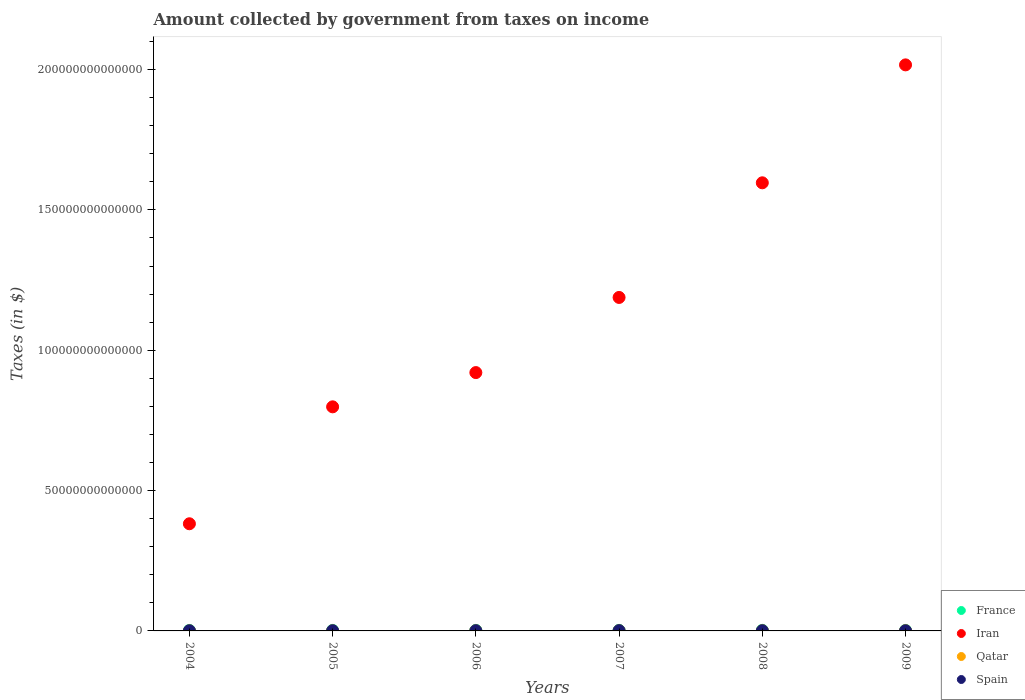How many different coloured dotlines are there?
Offer a very short reply. 4. What is the amount collected by government from taxes on income in Iran in 2007?
Your answer should be compact. 1.19e+14. Across all years, what is the maximum amount collected by government from taxes on income in France?
Make the answer very short. 2.04e+11. Across all years, what is the minimum amount collected by government from taxes on income in France?
Make the answer very short. 1.67e+11. In which year was the amount collected by government from taxes on income in Qatar minimum?
Provide a succinct answer. 2004. What is the total amount collected by government from taxes on income in Iran in the graph?
Keep it short and to the point. 6.90e+14. What is the difference between the amount collected by government from taxes on income in Iran in 2004 and that in 2007?
Provide a short and direct response. -8.06e+13. What is the difference between the amount collected by government from taxes on income in Iran in 2004 and the amount collected by government from taxes on income in Qatar in 2008?
Your answer should be compact. 3.81e+13. What is the average amount collected by government from taxes on income in Iran per year?
Keep it short and to the point. 1.15e+14. In the year 2007, what is the difference between the amount collected by government from taxes on income in Qatar and amount collected by government from taxes on income in Spain?
Ensure brevity in your answer.  -4.45e+1. In how many years, is the amount collected by government from taxes on income in Qatar greater than 60000000000000 $?
Give a very brief answer. 0. What is the ratio of the amount collected by government from taxes on income in Spain in 2007 to that in 2009?
Give a very brief answer. 1.73. Is the difference between the amount collected by government from taxes on income in Qatar in 2004 and 2007 greater than the difference between the amount collected by government from taxes on income in Spain in 2004 and 2007?
Your answer should be very brief. Yes. What is the difference between the highest and the second highest amount collected by government from taxes on income in France?
Your answer should be very brief. 6.48e+09. What is the difference between the highest and the lowest amount collected by government from taxes on income in Qatar?
Provide a short and direct response. 3.96e+1. In how many years, is the amount collected by government from taxes on income in France greater than the average amount collected by government from taxes on income in France taken over all years?
Your answer should be very brief. 3. Is the sum of the amount collected by government from taxes on income in Iran in 2006 and 2007 greater than the maximum amount collected by government from taxes on income in Qatar across all years?
Keep it short and to the point. Yes. Is it the case that in every year, the sum of the amount collected by government from taxes on income in Qatar and amount collected by government from taxes on income in France  is greater than the sum of amount collected by government from taxes on income in Spain and amount collected by government from taxes on income in Iran?
Offer a terse response. Yes. Does the amount collected by government from taxes on income in Spain monotonically increase over the years?
Your answer should be very brief. No. Is the amount collected by government from taxes on income in Iran strictly less than the amount collected by government from taxes on income in France over the years?
Give a very brief answer. No. How many dotlines are there?
Offer a very short reply. 4. What is the difference between two consecutive major ticks on the Y-axis?
Offer a very short reply. 5.00e+13. Are the values on the major ticks of Y-axis written in scientific E-notation?
Give a very brief answer. No. How are the legend labels stacked?
Offer a very short reply. Vertical. What is the title of the graph?
Give a very brief answer. Amount collected by government from taxes on income. What is the label or title of the X-axis?
Your answer should be compact. Years. What is the label or title of the Y-axis?
Ensure brevity in your answer.  Taxes (in $). What is the Taxes (in $) of France in 2004?
Make the answer very short. 1.70e+11. What is the Taxes (in $) of Iran in 2004?
Provide a succinct answer. 3.82e+13. What is the Taxes (in $) in Qatar in 2004?
Give a very brief answer. 2.83e+1. What is the Taxes (in $) in Spain in 2004?
Offer a terse response. 6.17e+1. What is the Taxes (in $) in France in 2005?
Your answer should be compact. 1.79e+11. What is the Taxes (in $) of Iran in 2005?
Your answer should be very brief. 7.98e+13. What is the Taxes (in $) of Qatar in 2005?
Make the answer very short. 3.12e+1. What is the Taxes (in $) in Spain in 2005?
Offer a terse response. 7.17e+1. What is the Taxes (in $) of France in 2006?
Offer a very short reply. 1.94e+11. What is the Taxes (in $) in Iran in 2006?
Keep it short and to the point. 9.20e+13. What is the Taxes (in $) in Qatar in 2006?
Keep it short and to the point. 4.17e+1. What is the Taxes (in $) of Spain in 2006?
Provide a short and direct response. 8.38e+1. What is the Taxes (in $) in France in 2007?
Provide a succinct answer. 1.98e+11. What is the Taxes (in $) in Iran in 2007?
Your answer should be compact. 1.19e+14. What is the Taxes (in $) in Qatar in 2007?
Give a very brief answer. 5.58e+1. What is the Taxes (in $) of Spain in 2007?
Your answer should be compact. 1.00e+11. What is the Taxes (in $) of France in 2008?
Give a very brief answer. 2.04e+11. What is the Taxes (in $) in Iran in 2008?
Offer a very short reply. 1.60e+14. What is the Taxes (in $) in Qatar in 2008?
Provide a short and direct response. 6.33e+1. What is the Taxes (in $) in Spain in 2008?
Provide a short and direct response. 7.50e+1. What is the Taxes (in $) in France in 2009?
Your answer should be compact. 1.67e+11. What is the Taxes (in $) in Iran in 2009?
Make the answer very short. 2.02e+14. What is the Taxes (in $) of Qatar in 2009?
Keep it short and to the point. 6.78e+1. What is the Taxes (in $) of Spain in 2009?
Provide a succinct answer. 5.79e+1. Across all years, what is the maximum Taxes (in $) in France?
Your response must be concise. 2.04e+11. Across all years, what is the maximum Taxes (in $) of Iran?
Provide a succinct answer. 2.02e+14. Across all years, what is the maximum Taxes (in $) in Qatar?
Ensure brevity in your answer.  6.78e+1. Across all years, what is the maximum Taxes (in $) of Spain?
Your answer should be very brief. 1.00e+11. Across all years, what is the minimum Taxes (in $) of France?
Give a very brief answer. 1.67e+11. Across all years, what is the minimum Taxes (in $) of Iran?
Your response must be concise. 3.82e+13. Across all years, what is the minimum Taxes (in $) of Qatar?
Your response must be concise. 2.83e+1. Across all years, what is the minimum Taxes (in $) in Spain?
Your answer should be very brief. 5.79e+1. What is the total Taxes (in $) of France in the graph?
Make the answer very short. 1.11e+12. What is the total Taxes (in $) of Iran in the graph?
Your response must be concise. 6.90e+14. What is the total Taxes (in $) of Qatar in the graph?
Your answer should be very brief. 2.88e+11. What is the total Taxes (in $) of Spain in the graph?
Your answer should be very brief. 4.50e+11. What is the difference between the Taxes (in $) in France in 2004 and that in 2005?
Your answer should be compact. -9.03e+09. What is the difference between the Taxes (in $) in Iran in 2004 and that in 2005?
Ensure brevity in your answer.  -4.17e+13. What is the difference between the Taxes (in $) of Qatar in 2004 and that in 2005?
Your answer should be very brief. -2.98e+09. What is the difference between the Taxes (in $) in Spain in 2004 and that in 2005?
Give a very brief answer. -1.01e+1. What is the difference between the Taxes (in $) in France in 2004 and that in 2006?
Give a very brief answer. -2.45e+1. What is the difference between the Taxes (in $) of Iran in 2004 and that in 2006?
Your answer should be compact. -5.39e+13. What is the difference between the Taxes (in $) in Qatar in 2004 and that in 2006?
Your response must be concise. -1.35e+1. What is the difference between the Taxes (in $) in Spain in 2004 and that in 2006?
Offer a terse response. -2.22e+1. What is the difference between the Taxes (in $) of France in 2004 and that in 2007?
Provide a succinct answer. -2.82e+1. What is the difference between the Taxes (in $) in Iran in 2004 and that in 2007?
Give a very brief answer. -8.06e+13. What is the difference between the Taxes (in $) in Qatar in 2004 and that in 2007?
Provide a succinct answer. -2.76e+1. What is the difference between the Taxes (in $) of Spain in 2004 and that in 2007?
Your response must be concise. -3.86e+1. What is the difference between the Taxes (in $) of France in 2004 and that in 2008?
Make the answer very short. -3.46e+1. What is the difference between the Taxes (in $) of Iran in 2004 and that in 2008?
Ensure brevity in your answer.  -1.21e+14. What is the difference between the Taxes (in $) in Qatar in 2004 and that in 2008?
Ensure brevity in your answer.  -3.50e+1. What is the difference between the Taxes (in $) of Spain in 2004 and that in 2008?
Your answer should be compact. -1.34e+1. What is the difference between the Taxes (in $) in France in 2004 and that in 2009?
Provide a short and direct response. 2.68e+09. What is the difference between the Taxes (in $) in Iran in 2004 and that in 2009?
Provide a short and direct response. -1.63e+14. What is the difference between the Taxes (in $) of Qatar in 2004 and that in 2009?
Give a very brief answer. -3.96e+1. What is the difference between the Taxes (in $) of Spain in 2004 and that in 2009?
Keep it short and to the point. 3.77e+09. What is the difference between the Taxes (in $) of France in 2005 and that in 2006?
Your response must be concise. -1.54e+1. What is the difference between the Taxes (in $) in Iran in 2005 and that in 2006?
Offer a very short reply. -1.22e+13. What is the difference between the Taxes (in $) of Qatar in 2005 and that in 2006?
Make the answer very short. -1.05e+1. What is the difference between the Taxes (in $) in Spain in 2005 and that in 2006?
Give a very brief answer. -1.21e+1. What is the difference between the Taxes (in $) of France in 2005 and that in 2007?
Give a very brief answer. -1.91e+1. What is the difference between the Taxes (in $) in Iran in 2005 and that in 2007?
Keep it short and to the point. -3.90e+13. What is the difference between the Taxes (in $) of Qatar in 2005 and that in 2007?
Provide a succinct answer. -2.46e+1. What is the difference between the Taxes (in $) in Spain in 2005 and that in 2007?
Provide a short and direct response. -2.86e+1. What is the difference between the Taxes (in $) of France in 2005 and that in 2008?
Your answer should be compact. -2.56e+1. What is the difference between the Taxes (in $) in Iran in 2005 and that in 2008?
Ensure brevity in your answer.  -7.98e+13. What is the difference between the Taxes (in $) in Qatar in 2005 and that in 2008?
Offer a very short reply. -3.20e+1. What is the difference between the Taxes (in $) of Spain in 2005 and that in 2008?
Provide a succinct answer. -3.30e+09. What is the difference between the Taxes (in $) of France in 2005 and that in 2009?
Your answer should be compact. 1.17e+1. What is the difference between the Taxes (in $) of Iran in 2005 and that in 2009?
Your answer should be compact. -1.22e+14. What is the difference between the Taxes (in $) of Qatar in 2005 and that in 2009?
Your answer should be very brief. -3.66e+1. What is the difference between the Taxes (in $) of Spain in 2005 and that in 2009?
Your answer should be very brief. 1.38e+1. What is the difference between the Taxes (in $) in France in 2006 and that in 2007?
Your response must be concise. -3.69e+09. What is the difference between the Taxes (in $) in Iran in 2006 and that in 2007?
Your answer should be compact. -2.68e+13. What is the difference between the Taxes (in $) of Qatar in 2006 and that in 2007?
Keep it short and to the point. -1.41e+1. What is the difference between the Taxes (in $) in Spain in 2006 and that in 2007?
Your answer should be very brief. -1.65e+1. What is the difference between the Taxes (in $) of France in 2006 and that in 2008?
Keep it short and to the point. -1.02e+1. What is the difference between the Taxes (in $) in Iran in 2006 and that in 2008?
Offer a terse response. -6.76e+13. What is the difference between the Taxes (in $) of Qatar in 2006 and that in 2008?
Keep it short and to the point. -2.15e+1. What is the difference between the Taxes (in $) of Spain in 2006 and that in 2008?
Your answer should be very brief. 8.80e+09. What is the difference between the Taxes (in $) of France in 2006 and that in 2009?
Your answer should be compact. 2.71e+1. What is the difference between the Taxes (in $) in Iran in 2006 and that in 2009?
Provide a short and direct response. -1.10e+14. What is the difference between the Taxes (in $) in Qatar in 2006 and that in 2009?
Your response must be concise. -2.61e+1. What is the difference between the Taxes (in $) in Spain in 2006 and that in 2009?
Give a very brief answer. 2.59e+1. What is the difference between the Taxes (in $) in France in 2007 and that in 2008?
Ensure brevity in your answer.  -6.48e+09. What is the difference between the Taxes (in $) of Iran in 2007 and that in 2008?
Provide a succinct answer. -4.08e+13. What is the difference between the Taxes (in $) in Qatar in 2007 and that in 2008?
Your response must be concise. -7.43e+09. What is the difference between the Taxes (in $) in Spain in 2007 and that in 2008?
Your answer should be very brief. 2.53e+1. What is the difference between the Taxes (in $) of France in 2007 and that in 2009?
Provide a succinct answer. 3.08e+1. What is the difference between the Taxes (in $) in Iran in 2007 and that in 2009?
Keep it short and to the point. -8.29e+13. What is the difference between the Taxes (in $) of Qatar in 2007 and that in 2009?
Give a very brief answer. -1.20e+1. What is the difference between the Taxes (in $) in Spain in 2007 and that in 2009?
Give a very brief answer. 4.24e+1. What is the difference between the Taxes (in $) in France in 2008 and that in 2009?
Keep it short and to the point. 3.73e+1. What is the difference between the Taxes (in $) of Iran in 2008 and that in 2009?
Provide a succinct answer. -4.20e+13. What is the difference between the Taxes (in $) in Qatar in 2008 and that in 2009?
Your answer should be compact. -4.54e+09. What is the difference between the Taxes (in $) of Spain in 2008 and that in 2009?
Your answer should be very brief. 1.71e+1. What is the difference between the Taxes (in $) in France in 2004 and the Taxes (in $) in Iran in 2005?
Your answer should be compact. -7.97e+13. What is the difference between the Taxes (in $) in France in 2004 and the Taxes (in $) in Qatar in 2005?
Your answer should be very brief. 1.38e+11. What is the difference between the Taxes (in $) in France in 2004 and the Taxes (in $) in Spain in 2005?
Give a very brief answer. 9.79e+1. What is the difference between the Taxes (in $) in Iran in 2004 and the Taxes (in $) in Qatar in 2005?
Provide a short and direct response. 3.81e+13. What is the difference between the Taxes (in $) in Iran in 2004 and the Taxes (in $) in Spain in 2005?
Provide a succinct answer. 3.81e+13. What is the difference between the Taxes (in $) of Qatar in 2004 and the Taxes (in $) of Spain in 2005?
Keep it short and to the point. -4.35e+1. What is the difference between the Taxes (in $) of France in 2004 and the Taxes (in $) of Iran in 2006?
Your answer should be very brief. -9.19e+13. What is the difference between the Taxes (in $) of France in 2004 and the Taxes (in $) of Qatar in 2006?
Make the answer very short. 1.28e+11. What is the difference between the Taxes (in $) of France in 2004 and the Taxes (in $) of Spain in 2006?
Keep it short and to the point. 8.58e+1. What is the difference between the Taxes (in $) in Iran in 2004 and the Taxes (in $) in Qatar in 2006?
Provide a short and direct response. 3.81e+13. What is the difference between the Taxes (in $) of Iran in 2004 and the Taxes (in $) of Spain in 2006?
Ensure brevity in your answer.  3.81e+13. What is the difference between the Taxes (in $) of Qatar in 2004 and the Taxes (in $) of Spain in 2006?
Your answer should be very brief. -5.56e+1. What is the difference between the Taxes (in $) of France in 2004 and the Taxes (in $) of Iran in 2007?
Your answer should be compact. -1.19e+14. What is the difference between the Taxes (in $) of France in 2004 and the Taxes (in $) of Qatar in 2007?
Ensure brevity in your answer.  1.14e+11. What is the difference between the Taxes (in $) in France in 2004 and the Taxes (in $) in Spain in 2007?
Keep it short and to the point. 6.94e+1. What is the difference between the Taxes (in $) of Iran in 2004 and the Taxes (in $) of Qatar in 2007?
Offer a very short reply. 3.81e+13. What is the difference between the Taxes (in $) in Iran in 2004 and the Taxes (in $) in Spain in 2007?
Offer a terse response. 3.81e+13. What is the difference between the Taxes (in $) in Qatar in 2004 and the Taxes (in $) in Spain in 2007?
Make the answer very short. -7.20e+1. What is the difference between the Taxes (in $) in France in 2004 and the Taxes (in $) in Iran in 2008?
Your response must be concise. -1.59e+14. What is the difference between the Taxes (in $) of France in 2004 and the Taxes (in $) of Qatar in 2008?
Your answer should be compact. 1.06e+11. What is the difference between the Taxes (in $) in France in 2004 and the Taxes (in $) in Spain in 2008?
Your response must be concise. 9.46e+1. What is the difference between the Taxes (in $) of Iran in 2004 and the Taxes (in $) of Qatar in 2008?
Give a very brief answer. 3.81e+13. What is the difference between the Taxes (in $) in Iran in 2004 and the Taxes (in $) in Spain in 2008?
Provide a short and direct response. 3.81e+13. What is the difference between the Taxes (in $) in Qatar in 2004 and the Taxes (in $) in Spain in 2008?
Offer a very short reply. -4.68e+1. What is the difference between the Taxes (in $) of France in 2004 and the Taxes (in $) of Iran in 2009?
Provide a short and direct response. -2.01e+14. What is the difference between the Taxes (in $) of France in 2004 and the Taxes (in $) of Qatar in 2009?
Provide a short and direct response. 1.02e+11. What is the difference between the Taxes (in $) in France in 2004 and the Taxes (in $) in Spain in 2009?
Your response must be concise. 1.12e+11. What is the difference between the Taxes (in $) in Iran in 2004 and the Taxes (in $) in Qatar in 2009?
Your answer should be compact. 3.81e+13. What is the difference between the Taxes (in $) of Iran in 2004 and the Taxes (in $) of Spain in 2009?
Make the answer very short. 3.81e+13. What is the difference between the Taxes (in $) of Qatar in 2004 and the Taxes (in $) of Spain in 2009?
Ensure brevity in your answer.  -2.97e+1. What is the difference between the Taxes (in $) of France in 2005 and the Taxes (in $) of Iran in 2006?
Ensure brevity in your answer.  -9.19e+13. What is the difference between the Taxes (in $) in France in 2005 and the Taxes (in $) in Qatar in 2006?
Make the answer very short. 1.37e+11. What is the difference between the Taxes (in $) of France in 2005 and the Taxes (in $) of Spain in 2006?
Make the answer very short. 9.49e+1. What is the difference between the Taxes (in $) in Iran in 2005 and the Taxes (in $) in Qatar in 2006?
Offer a very short reply. 7.98e+13. What is the difference between the Taxes (in $) in Iran in 2005 and the Taxes (in $) in Spain in 2006?
Ensure brevity in your answer.  7.98e+13. What is the difference between the Taxes (in $) of Qatar in 2005 and the Taxes (in $) of Spain in 2006?
Make the answer very short. -5.26e+1. What is the difference between the Taxes (in $) in France in 2005 and the Taxes (in $) in Iran in 2007?
Offer a terse response. -1.19e+14. What is the difference between the Taxes (in $) of France in 2005 and the Taxes (in $) of Qatar in 2007?
Your answer should be very brief. 1.23e+11. What is the difference between the Taxes (in $) of France in 2005 and the Taxes (in $) of Spain in 2007?
Provide a succinct answer. 7.84e+1. What is the difference between the Taxes (in $) of Iran in 2005 and the Taxes (in $) of Qatar in 2007?
Your answer should be very brief. 7.98e+13. What is the difference between the Taxes (in $) of Iran in 2005 and the Taxes (in $) of Spain in 2007?
Your answer should be very brief. 7.97e+13. What is the difference between the Taxes (in $) in Qatar in 2005 and the Taxes (in $) in Spain in 2007?
Ensure brevity in your answer.  -6.91e+1. What is the difference between the Taxes (in $) in France in 2005 and the Taxes (in $) in Iran in 2008?
Give a very brief answer. -1.59e+14. What is the difference between the Taxes (in $) in France in 2005 and the Taxes (in $) in Qatar in 2008?
Your answer should be compact. 1.15e+11. What is the difference between the Taxes (in $) in France in 2005 and the Taxes (in $) in Spain in 2008?
Your answer should be compact. 1.04e+11. What is the difference between the Taxes (in $) in Iran in 2005 and the Taxes (in $) in Qatar in 2008?
Offer a very short reply. 7.98e+13. What is the difference between the Taxes (in $) in Iran in 2005 and the Taxes (in $) in Spain in 2008?
Offer a very short reply. 7.98e+13. What is the difference between the Taxes (in $) in Qatar in 2005 and the Taxes (in $) in Spain in 2008?
Your response must be concise. -4.38e+1. What is the difference between the Taxes (in $) of France in 2005 and the Taxes (in $) of Iran in 2009?
Make the answer very short. -2.01e+14. What is the difference between the Taxes (in $) of France in 2005 and the Taxes (in $) of Qatar in 2009?
Offer a very short reply. 1.11e+11. What is the difference between the Taxes (in $) of France in 2005 and the Taxes (in $) of Spain in 2009?
Provide a succinct answer. 1.21e+11. What is the difference between the Taxes (in $) in Iran in 2005 and the Taxes (in $) in Qatar in 2009?
Ensure brevity in your answer.  7.98e+13. What is the difference between the Taxes (in $) of Iran in 2005 and the Taxes (in $) of Spain in 2009?
Make the answer very short. 7.98e+13. What is the difference between the Taxes (in $) in Qatar in 2005 and the Taxes (in $) in Spain in 2009?
Your answer should be compact. -2.67e+1. What is the difference between the Taxes (in $) of France in 2006 and the Taxes (in $) of Iran in 2007?
Provide a succinct answer. -1.19e+14. What is the difference between the Taxes (in $) in France in 2006 and the Taxes (in $) in Qatar in 2007?
Your answer should be compact. 1.38e+11. What is the difference between the Taxes (in $) in France in 2006 and the Taxes (in $) in Spain in 2007?
Ensure brevity in your answer.  9.38e+1. What is the difference between the Taxes (in $) of Iran in 2006 and the Taxes (in $) of Qatar in 2007?
Make the answer very short. 9.20e+13. What is the difference between the Taxes (in $) in Iran in 2006 and the Taxes (in $) in Spain in 2007?
Ensure brevity in your answer.  9.19e+13. What is the difference between the Taxes (in $) in Qatar in 2006 and the Taxes (in $) in Spain in 2007?
Your response must be concise. -5.86e+1. What is the difference between the Taxes (in $) in France in 2006 and the Taxes (in $) in Iran in 2008?
Your answer should be very brief. -1.59e+14. What is the difference between the Taxes (in $) in France in 2006 and the Taxes (in $) in Qatar in 2008?
Keep it short and to the point. 1.31e+11. What is the difference between the Taxes (in $) of France in 2006 and the Taxes (in $) of Spain in 2008?
Your answer should be very brief. 1.19e+11. What is the difference between the Taxes (in $) of Iran in 2006 and the Taxes (in $) of Qatar in 2008?
Keep it short and to the point. 9.20e+13. What is the difference between the Taxes (in $) in Iran in 2006 and the Taxes (in $) in Spain in 2008?
Offer a terse response. 9.20e+13. What is the difference between the Taxes (in $) in Qatar in 2006 and the Taxes (in $) in Spain in 2008?
Make the answer very short. -3.33e+1. What is the difference between the Taxes (in $) of France in 2006 and the Taxes (in $) of Iran in 2009?
Keep it short and to the point. -2.01e+14. What is the difference between the Taxes (in $) of France in 2006 and the Taxes (in $) of Qatar in 2009?
Your response must be concise. 1.26e+11. What is the difference between the Taxes (in $) of France in 2006 and the Taxes (in $) of Spain in 2009?
Your answer should be very brief. 1.36e+11. What is the difference between the Taxes (in $) in Iran in 2006 and the Taxes (in $) in Qatar in 2009?
Keep it short and to the point. 9.20e+13. What is the difference between the Taxes (in $) of Iran in 2006 and the Taxes (in $) of Spain in 2009?
Keep it short and to the point. 9.20e+13. What is the difference between the Taxes (in $) in Qatar in 2006 and the Taxes (in $) in Spain in 2009?
Ensure brevity in your answer.  -1.62e+1. What is the difference between the Taxes (in $) in France in 2007 and the Taxes (in $) in Iran in 2008?
Give a very brief answer. -1.59e+14. What is the difference between the Taxes (in $) of France in 2007 and the Taxes (in $) of Qatar in 2008?
Offer a very short reply. 1.35e+11. What is the difference between the Taxes (in $) in France in 2007 and the Taxes (in $) in Spain in 2008?
Ensure brevity in your answer.  1.23e+11. What is the difference between the Taxes (in $) in Iran in 2007 and the Taxes (in $) in Qatar in 2008?
Your response must be concise. 1.19e+14. What is the difference between the Taxes (in $) of Iran in 2007 and the Taxes (in $) of Spain in 2008?
Your answer should be compact. 1.19e+14. What is the difference between the Taxes (in $) in Qatar in 2007 and the Taxes (in $) in Spain in 2008?
Offer a terse response. -1.92e+1. What is the difference between the Taxes (in $) of France in 2007 and the Taxes (in $) of Iran in 2009?
Keep it short and to the point. -2.01e+14. What is the difference between the Taxes (in $) of France in 2007 and the Taxes (in $) of Qatar in 2009?
Your answer should be compact. 1.30e+11. What is the difference between the Taxes (in $) in France in 2007 and the Taxes (in $) in Spain in 2009?
Give a very brief answer. 1.40e+11. What is the difference between the Taxes (in $) of Iran in 2007 and the Taxes (in $) of Qatar in 2009?
Keep it short and to the point. 1.19e+14. What is the difference between the Taxes (in $) in Iran in 2007 and the Taxes (in $) in Spain in 2009?
Your response must be concise. 1.19e+14. What is the difference between the Taxes (in $) of Qatar in 2007 and the Taxes (in $) of Spain in 2009?
Offer a very short reply. -2.07e+09. What is the difference between the Taxes (in $) of France in 2008 and the Taxes (in $) of Iran in 2009?
Your answer should be very brief. -2.01e+14. What is the difference between the Taxes (in $) in France in 2008 and the Taxes (in $) in Qatar in 2009?
Give a very brief answer. 1.36e+11. What is the difference between the Taxes (in $) in France in 2008 and the Taxes (in $) in Spain in 2009?
Your answer should be very brief. 1.46e+11. What is the difference between the Taxes (in $) of Iran in 2008 and the Taxes (in $) of Qatar in 2009?
Your answer should be compact. 1.60e+14. What is the difference between the Taxes (in $) in Iran in 2008 and the Taxes (in $) in Spain in 2009?
Your answer should be compact. 1.60e+14. What is the difference between the Taxes (in $) in Qatar in 2008 and the Taxes (in $) in Spain in 2009?
Provide a short and direct response. 5.36e+09. What is the average Taxes (in $) in France per year?
Provide a short and direct response. 1.85e+11. What is the average Taxes (in $) of Iran per year?
Ensure brevity in your answer.  1.15e+14. What is the average Taxes (in $) in Qatar per year?
Your response must be concise. 4.80e+1. What is the average Taxes (in $) in Spain per year?
Your answer should be compact. 7.51e+1. In the year 2004, what is the difference between the Taxes (in $) in France and Taxes (in $) in Iran?
Provide a short and direct response. -3.80e+13. In the year 2004, what is the difference between the Taxes (in $) of France and Taxes (in $) of Qatar?
Provide a short and direct response. 1.41e+11. In the year 2004, what is the difference between the Taxes (in $) in France and Taxes (in $) in Spain?
Give a very brief answer. 1.08e+11. In the year 2004, what is the difference between the Taxes (in $) in Iran and Taxes (in $) in Qatar?
Keep it short and to the point. 3.81e+13. In the year 2004, what is the difference between the Taxes (in $) of Iran and Taxes (in $) of Spain?
Offer a terse response. 3.81e+13. In the year 2004, what is the difference between the Taxes (in $) of Qatar and Taxes (in $) of Spain?
Give a very brief answer. -3.34e+1. In the year 2005, what is the difference between the Taxes (in $) in France and Taxes (in $) in Iran?
Your response must be concise. -7.97e+13. In the year 2005, what is the difference between the Taxes (in $) of France and Taxes (in $) of Qatar?
Ensure brevity in your answer.  1.47e+11. In the year 2005, what is the difference between the Taxes (in $) of France and Taxes (in $) of Spain?
Offer a terse response. 1.07e+11. In the year 2005, what is the difference between the Taxes (in $) in Iran and Taxes (in $) in Qatar?
Your response must be concise. 7.98e+13. In the year 2005, what is the difference between the Taxes (in $) of Iran and Taxes (in $) of Spain?
Offer a terse response. 7.98e+13. In the year 2005, what is the difference between the Taxes (in $) in Qatar and Taxes (in $) in Spain?
Make the answer very short. -4.05e+1. In the year 2006, what is the difference between the Taxes (in $) in France and Taxes (in $) in Iran?
Your answer should be compact. -9.18e+13. In the year 2006, what is the difference between the Taxes (in $) of France and Taxes (in $) of Qatar?
Keep it short and to the point. 1.52e+11. In the year 2006, what is the difference between the Taxes (in $) in France and Taxes (in $) in Spain?
Offer a terse response. 1.10e+11. In the year 2006, what is the difference between the Taxes (in $) of Iran and Taxes (in $) of Qatar?
Provide a short and direct response. 9.20e+13. In the year 2006, what is the difference between the Taxes (in $) in Iran and Taxes (in $) in Spain?
Ensure brevity in your answer.  9.20e+13. In the year 2006, what is the difference between the Taxes (in $) of Qatar and Taxes (in $) of Spain?
Your answer should be very brief. -4.21e+1. In the year 2007, what is the difference between the Taxes (in $) in France and Taxes (in $) in Iran?
Ensure brevity in your answer.  -1.19e+14. In the year 2007, what is the difference between the Taxes (in $) of France and Taxes (in $) of Qatar?
Offer a terse response. 1.42e+11. In the year 2007, what is the difference between the Taxes (in $) of France and Taxes (in $) of Spain?
Make the answer very short. 9.75e+1. In the year 2007, what is the difference between the Taxes (in $) in Iran and Taxes (in $) in Qatar?
Offer a very short reply. 1.19e+14. In the year 2007, what is the difference between the Taxes (in $) of Iran and Taxes (in $) of Spain?
Your response must be concise. 1.19e+14. In the year 2007, what is the difference between the Taxes (in $) of Qatar and Taxes (in $) of Spain?
Provide a succinct answer. -4.45e+1. In the year 2008, what is the difference between the Taxes (in $) of France and Taxes (in $) of Iran?
Give a very brief answer. -1.59e+14. In the year 2008, what is the difference between the Taxes (in $) in France and Taxes (in $) in Qatar?
Offer a very short reply. 1.41e+11. In the year 2008, what is the difference between the Taxes (in $) in France and Taxes (in $) in Spain?
Provide a short and direct response. 1.29e+11. In the year 2008, what is the difference between the Taxes (in $) in Iran and Taxes (in $) in Qatar?
Provide a short and direct response. 1.60e+14. In the year 2008, what is the difference between the Taxes (in $) in Iran and Taxes (in $) in Spain?
Offer a terse response. 1.60e+14. In the year 2008, what is the difference between the Taxes (in $) of Qatar and Taxes (in $) of Spain?
Keep it short and to the point. -1.18e+1. In the year 2009, what is the difference between the Taxes (in $) in France and Taxes (in $) in Iran?
Offer a terse response. -2.01e+14. In the year 2009, what is the difference between the Taxes (in $) in France and Taxes (in $) in Qatar?
Your answer should be very brief. 9.92e+1. In the year 2009, what is the difference between the Taxes (in $) in France and Taxes (in $) in Spain?
Ensure brevity in your answer.  1.09e+11. In the year 2009, what is the difference between the Taxes (in $) of Iran and Taxes (in $) of Qatar?
Your answer should be compact. 2.02e+14. In the year 2009, what is the difference between the Taxes (in $) of Iran and Taxes (in $) of Spain?
Offer a terse response. 2.02e+14. In the year 2009, what is the difference between the Taxes (in $) of Qatar and Taxes (in $) of Spain?
Your answer should be very brief. 9.90e+09. What is the ratio of the Taxes (in $) of France in 2004 to that in 2005?
Your answer should be compact. 0.95. What is the ratio of the Taxes (in $) of Iran in 2004 to that in 2005?
Offer a very short reply. 0.48. What is the ratio of the Taxes (in $) of Qatar in 2004 to that in 2005?
Ensure brevity in your answer.  0.9. What is the ratio of the Taxes (in $) of Spain in 2004 to that in 2005?
Make the answer very short. 0.86. What is the ratio of the Taxes (in $) of France in 2004 to that in 2006?
Offer a terse response. 0.87. What is the ratio of the Taxes (in $) of Iran in 2004 to that in 2006?
Your answer should be compact. 0.41. What is the ratio of the Taxes (in $) in Qatar in 2004 to that in 2006?
Offer a very short reply. 0.68. What is the ratio of the Taxes (in $) in Spain in 2004 to that in 2006?
Your answer should be very brief. 0.74. What is the ratio of the Taxes (in $) in France in 2004 to that in 2007?
Offer a very short reply. 0.86. What is the ratio of the Taxes (in $) in Iran in 2004 to that in 2007?
Your response must be concise. 0.32. What is the ratio of the Taxes (in $) in Qatar in 2004 to that in 2007?
Provide a short and direct response. 0.51. What is the ratio of the Taxes (in $) of Spain in 2004 to that in 2007?
Give a very brief answer. 0.61. What is the ratio of the Taxes (in $) of France in 2004 to that in 2008?
Give a very brief answer. 0.83. What is the ratio of the Taxes (in $) in Iran in 2004 to that in 2008?
Give a very brief answer. 0.24. What is the ratio of the Taxes (in $) of Qatar in 2004 to that in 2008?
Provide a short and direct response. 0.45. What is the ratio of the Taxes (in $) in Spain in 2004 to that in 2008?
Your answer should be compact. 0.82. What is the ratio of the Taxes (in $) of France in 2004 to that in 2009?
Make the answer very short. 1.02. What is the ratio of the Taxes (in $) in Iran in 2004 to that in 2009?
Ensure brevity in your answer.  0.19. What is the ratio of the Taxes (in $) of Qatar in 2004 to that in 2009?
Offer a very short reply. 0.42. What is the ratio of the Taxes (in $) of Spain in 2004 to that in 2009?
Give a very brief answer. 1.06. What is the ratio of the Taxes (in $) in France in 2005 to that in 2006?
Offer a very short reply. 0.92. What is the ratio of the Taxes (in $) of Iran in 2005 to that in 2006?
Offer a terse response. 0.87. What is the ratio of the Taxes (in $) in Qatar in 2005 to that in 2006?
Offer a terse response. 0.75. What is the ratio of the Taxes (in $) of Spain in 2005 to that in 2006?
Your answer should be very brief. 0.86. What is the ratio of the Taxes (in $) of France in 2005 to that in 2007?
Your response must be concise. 0.9. What is the ratio of the Taxes (in $) of Iran in 2005 to that in 2007?
Provide a short and direct response. 0.67. What is the ratio of the Taxes (in $) of Qatar in 2005 to that in 2007?
Give a very brief answer. 0.56. What is the ratio of the Taxes (in $) of Spain in 2005 to that in 2007?
Give a very brief answer. 0.72. What is the ratio of the Taxes (in $) of France in 2005 to that in 2008?
Your response must be concise. 0.87. What is the ratio of the Taxes (in $) of Iran in 2005 to that in 2008?
Your answer should be compact. 0.5. What is the ratio of the Taxes (in $) in Qatar in 2005 to that in 2008?
Provide a succinct answer. 0.49. What is the ratio of the Taxes (in $) in Spain in 2005 to that in 2008?
Your response must be concise. 0.96. What is the ratio of the Taxes (in $) in France in 2005 to that in 2009?
Your response must be concise. 1.07. What is the ratio of the Taxes (in $) in Iran in 2005 to that in 2009?
Your answer should be very brief. 0.4. What is the ratio of the Taxes (in $) in Qatar in 2005 to that in 2009?
Make the answer very short. 0.46. What is the ratio of the Taxes (in $) in Spain in 2005 to that in 2009?
Provide a short and direct response. 1.24. What is the ratio of the Taxes (in $) in France in 2006 to that in 2007?
Provide a short and direct response. 0.98. What is the ratio of the Taxes (in $) of Iran in 2006 to that in 2007?
Offer a very short reply. 0.77. What is the ratio of the Taxes (in $) of Qatar in 2006 to that in 2007?
Ensure brevity in your answer.  0.75. What is the ratio of the Taxes (in $) of Spain in 2006 to that in 2007?
Provide a succinct answer. 0.84. What is the ratio of the Taxes (in $) of France in 2006 to that in 2008?
Provide a succinct answer. 0.95. What is the ratio of the Taxes (in $) in Iran in 2006 to that in 2008?
Provide a short and direct response. 0.58. What is the ratio of the Taxes (in $) of Qatar in 2006 to that in 2008?
Offer a terse response. 0.66. What is the ratio of the Taxes (in $) of Spain in 2006 to that in 2008?
Your answer should be very brief. 1.12. What is the ratio of the Taxes (in $) in France in 2006 to that in 2009?
Offer a terse response. 1.16. What is the ratio of the Taxes (in $) in Iran in 2006 to that in 2009?
Provide a short and direct response. 0.46. What is the ratio of the Taxes (in $) in Qatar in 2006 to that in 2009?
Make the answer very short. 0.62. What is the ratio of the Taxes (in $) of Spain in 2006 to that in 2009?
Your answer should be compact. 1.45. What is the ratio of the Taxes (in $) of France in 2007 to that in 2008?
Your answer should be compact. 0.97. What is the ratio of the Taxes (in $) of Iran in 2007 to that in 2008?
Offer a terse response. 0.74. What is the ratio of the Taxes (in $) of Qatar in 2007 to that in 2008?
Provide a succinct answer. 0.88. What is the ratio of the Taxes (in $) in Spain in 2007 to that in 2008?
Provide a short and direct response. 1.34. What is the ratio of the Taxes (in $) of France in 2007 to that in 2009?
Provide a short and direct response. 1.18. What is the ratio of the Taxes (in $) of Iran in 2007 to that in 2009?
Your response must be concise. 0.59. What is the ratio of the Taxes (in $) of Qatar in 2007 to that in 2009?
Provide a succinct answer. 0.82. What is the ratio of the Taxes (in $) in Spain in 2007 to that in 2009?
Provide a short and direct response. 1.73. What is the ratio of the Taxes (in $) in France in 2008 to that in 2009?
Provide a succinct answer. 1.22. What is the ratio of the Taxes (in $) of Iran in 2008 to that in 2009?
Ensure brevity in your answer.  0.79. What is the ratio of the Taxes (in $) of Qatar in 2008 to that in 2009?
Keep it short and to the point. 0.93. What is the ratio of the Taxes (in $) in Spain in 2008 to that in 2009?
Provide a succinct answer. 1.3. What is the difference between the highest and the second highest Taxes (in $) of France?
Give a very brief answer. 6.48e+09. What is the difference between the highest and the second highest Taxes (in $) of Iran?
Your answer should be very brief. 4.20e+13. What is the difference between the highest and the second highest Taxes (in $) of Qatar?
Keep it short and to the point. 4.54e+09. What is the difference between the highest and the second highest Taxes (in $) of Spain?
Your response must be concise. 1.65e+1. What is the difference between the highest and the lowest Taxes (in $) in France?
Your answer should be compact. 3.73e+1. What is the difference between the highest and the lowest Taxes (in $) in Iran?
Your answer should be compact. 1.63e+14. What is the difference between the highest and the lowest Taxes (in $) of Qatar?
Provide a succinct answer. 3.96e+1. What is the difference between the highest and the lowest Taxes (in $) of Spain?
Your answer should be compact. 4.24e+1. 